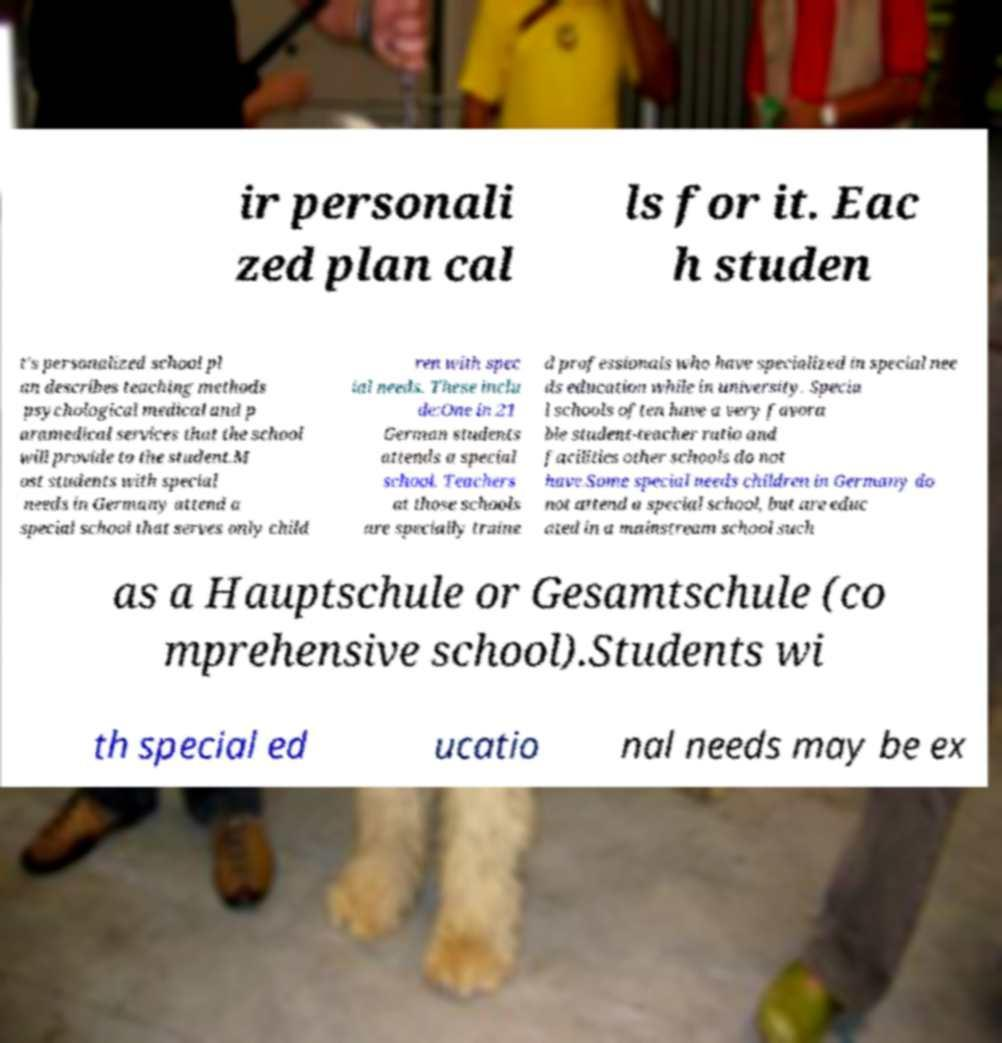What messages or text are displayed in this image? I need them in a readable, typed format. ir personali zed plan cal ls for it. Eac h studen t's personalized school pl an describes teaching methods psychological medical and p aramedical services that the school will provide to the student.M ost students with special needs in Germany attend a special school that serves only child ren with spec ial needs. These inclu de:One in 21 German students attends a special school. Teachers at those schools are specially traine d professionals who have specialized in special nee ds education while in university. Specia l schools often have a very favora ble student-teacher ratio and facilities other schools do not have.Some special needs children in Germany do not attend a special school, but are educ ated in a mainstream school such as a Hauptschule or Gesamtschule (co mprehensive school).Students wi th special ed ucatio nal needs may be ex 